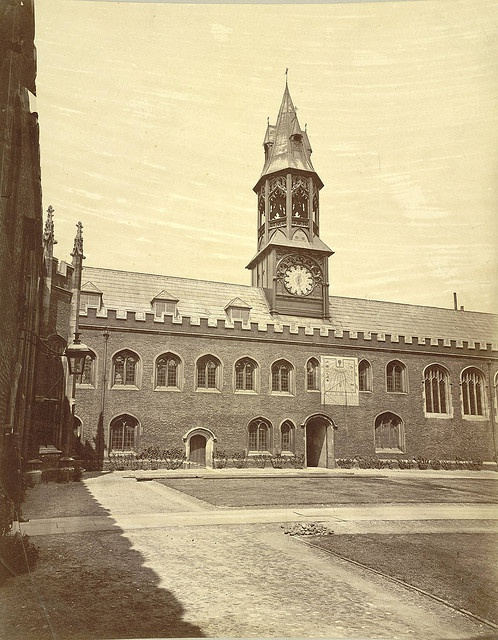Describe the objects in this image and their specific colors. I can see a clock in gray, beige, and tan tones in this image. 